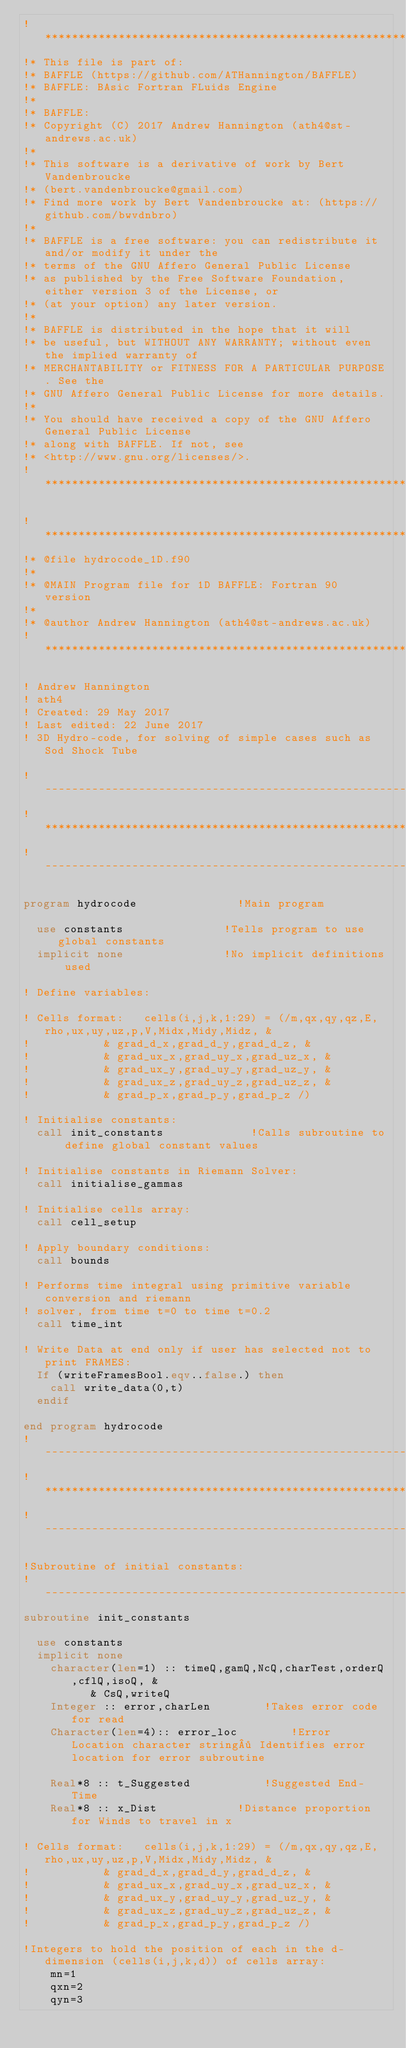Convert code to text. <code><loc_0><loc_0><loc_500><loc_500><_FORTRAN_>!********************************************************************************
!* This file is part of:
!* BAFFLE (https://github.com/ATHannington/BAFFLE)
!* BAFFLE: BAsic Fortran FLuids Engine
!*
!* BAFFLE:
!* Copyright (C) 2017 Andrew Hannington (ath4@st-andrews.ac.uk)
!*
!* This software is a derivative of work by Bert Vandenbroucke
!* (bert.vandenbroucke@gmail.com)
!* Find more work by Bert Vandenbroucke at: (https://github.com/bwvdnbro)
!*
!* BAFFLE is a free software: you can redistribute it and/or modify it under the 
!* terms of the GNU Affero General Public License
!* as published by the Free Software Foundation, either version 3 of the License, or
!* (at your option) any later version.
!*
!* BAFFLE is distributed in the hope that it will 
!* be useful, but WITHOUT ANY WARRANTY; without even the implied warranty of
!* MERCHANTABILITY or FITNESS FOR A PARTICULAR PURPOSE. See the
!* GNU Affero General Public License for more details.
!*
!* You should have received a copy of the GNU Affero General Public License
!* along with BAFFLE. If not, see
!* <http://www.gnu.org/licenses/>.
!********************************************************************************

!********************************************************************************
!* @file hydrocode_1D.f90
!*
!* @MAIN Program file for 1D BAFFLE: Fortran 90 version
!*
!* @author Andrew Hannington (ath4@st-andrews.ac.uk)
!********************************************************************************

! Andrew Hannington								
! ath4
! Created: 29 May 2017
! Last edited: 22 June 2017
! 3D Hydro-code, for solving of simple cases such as Sod Shock Tube

!-------------------------------------------------------------------------------
!*******************************************************************************
!-------------------------------------------------------------------------------

program hydrocode								!Main program

	use constants								!Tells program to use global constants
	implicit none								!No implicit definitions used

!	Define variables:

!	Cells format: 	cells(i,j,k,1:29) = (/m,qx,qy,qz,E,rho,ux,uy,uz,p,V,Midx,Midy,Midz, &
!						& grad_d_x,grad_d_y,grad_d_z, &
!						& grad_ux_x,grad_uy_x,grad_uz_x, &
!						& grad_ux_y,grad_uy_y,grad_uz_y, &
!						& grad_ux_z,grad_uy_z,grad_uz_z, &
!						& grad_p_x,grad_p_y,grad_p_z /)		

!	Initialise constants:
	call init_constants							!Calls subroutine to define global constant values

!	Initialise constants in Riemann Solver:
	call initialise_gammas

!	Initialise cells array:
	call cell_setup

!	Apply boundary conditions:
	call bounds

!	Performs time integral using primitive variable conversion and riemann
!	solver, from time t=0 to time t=0.2
	call time_int

!	Write Data at end only if user has selected not to print FRAMES:
	If (writeFramesBool.eqv..false.) then
		call write_data(0,t)
	endif

end program hydrocode
!-------------------------------------------------------------------------------
!*******************************************************************************
!-------------------------------------------------------------------------------

!Subroutine of initial constants:
!-------------------------------------------------------------------------------
subroutine init_constants							

	use constants
	implicit none
		character(len=1) :: timeQ,gamQ,NcQ,charTest,orderQ,cflQ,isoQ, &
				  & CsQ,writeQ
		Integer :: error,charLen				!Takes error code for read
		Character(len=4):: error_loc				!Error Location character string· Identifies error location for error subroutine

		Real*8 :: t_Suggested						!Suggested End-Time
		Real*8 :: x_Dist						!Distance proportion for Winds to travel in x

!	Cells format: 	cells(i,j,k,1:29) = (/m,qx,qy,qz,E,rho,ux,uy,uz,p,V,Midx,Midy,Midz, &
!						& grad_d_x,grad_d_y,grad_d_z, &
!						& grad_ux_x,grad_uy_x,grad_uz_x, &
!						& grad_ux_y,grad_uy_y,grad_uz_y, &
!						& grad_ux_z,grad_uy_z,grad_uz_z, &
!						& grad_p_x,grad_p_y,grad_p_z /)			

!Integers to hold the position of each in the d-dimension (cells(i,j,k,d)) of cells array:
 		mn=1
		qxn=2
		qyn=3</code> 